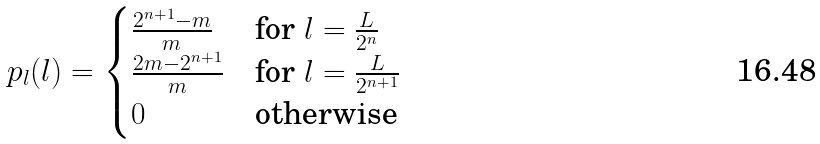Convert formula to latex. <formula><loc_0><loc_0><loc_500><loc_500>p _ { l } ( l ) = \begin{cases} \frac { 2 ^ { n + 1 } - m } { m } & \text {for } l = \frac { L } { 2 ^ { n } } \\ \frac { 2 m - 2 ^ { n + 1 } } { m } & \text {for } l = \frac { L } { 2 ^ { n + 1 } } \\ 0 & \text {otherwise} \end{cases}</formula> 